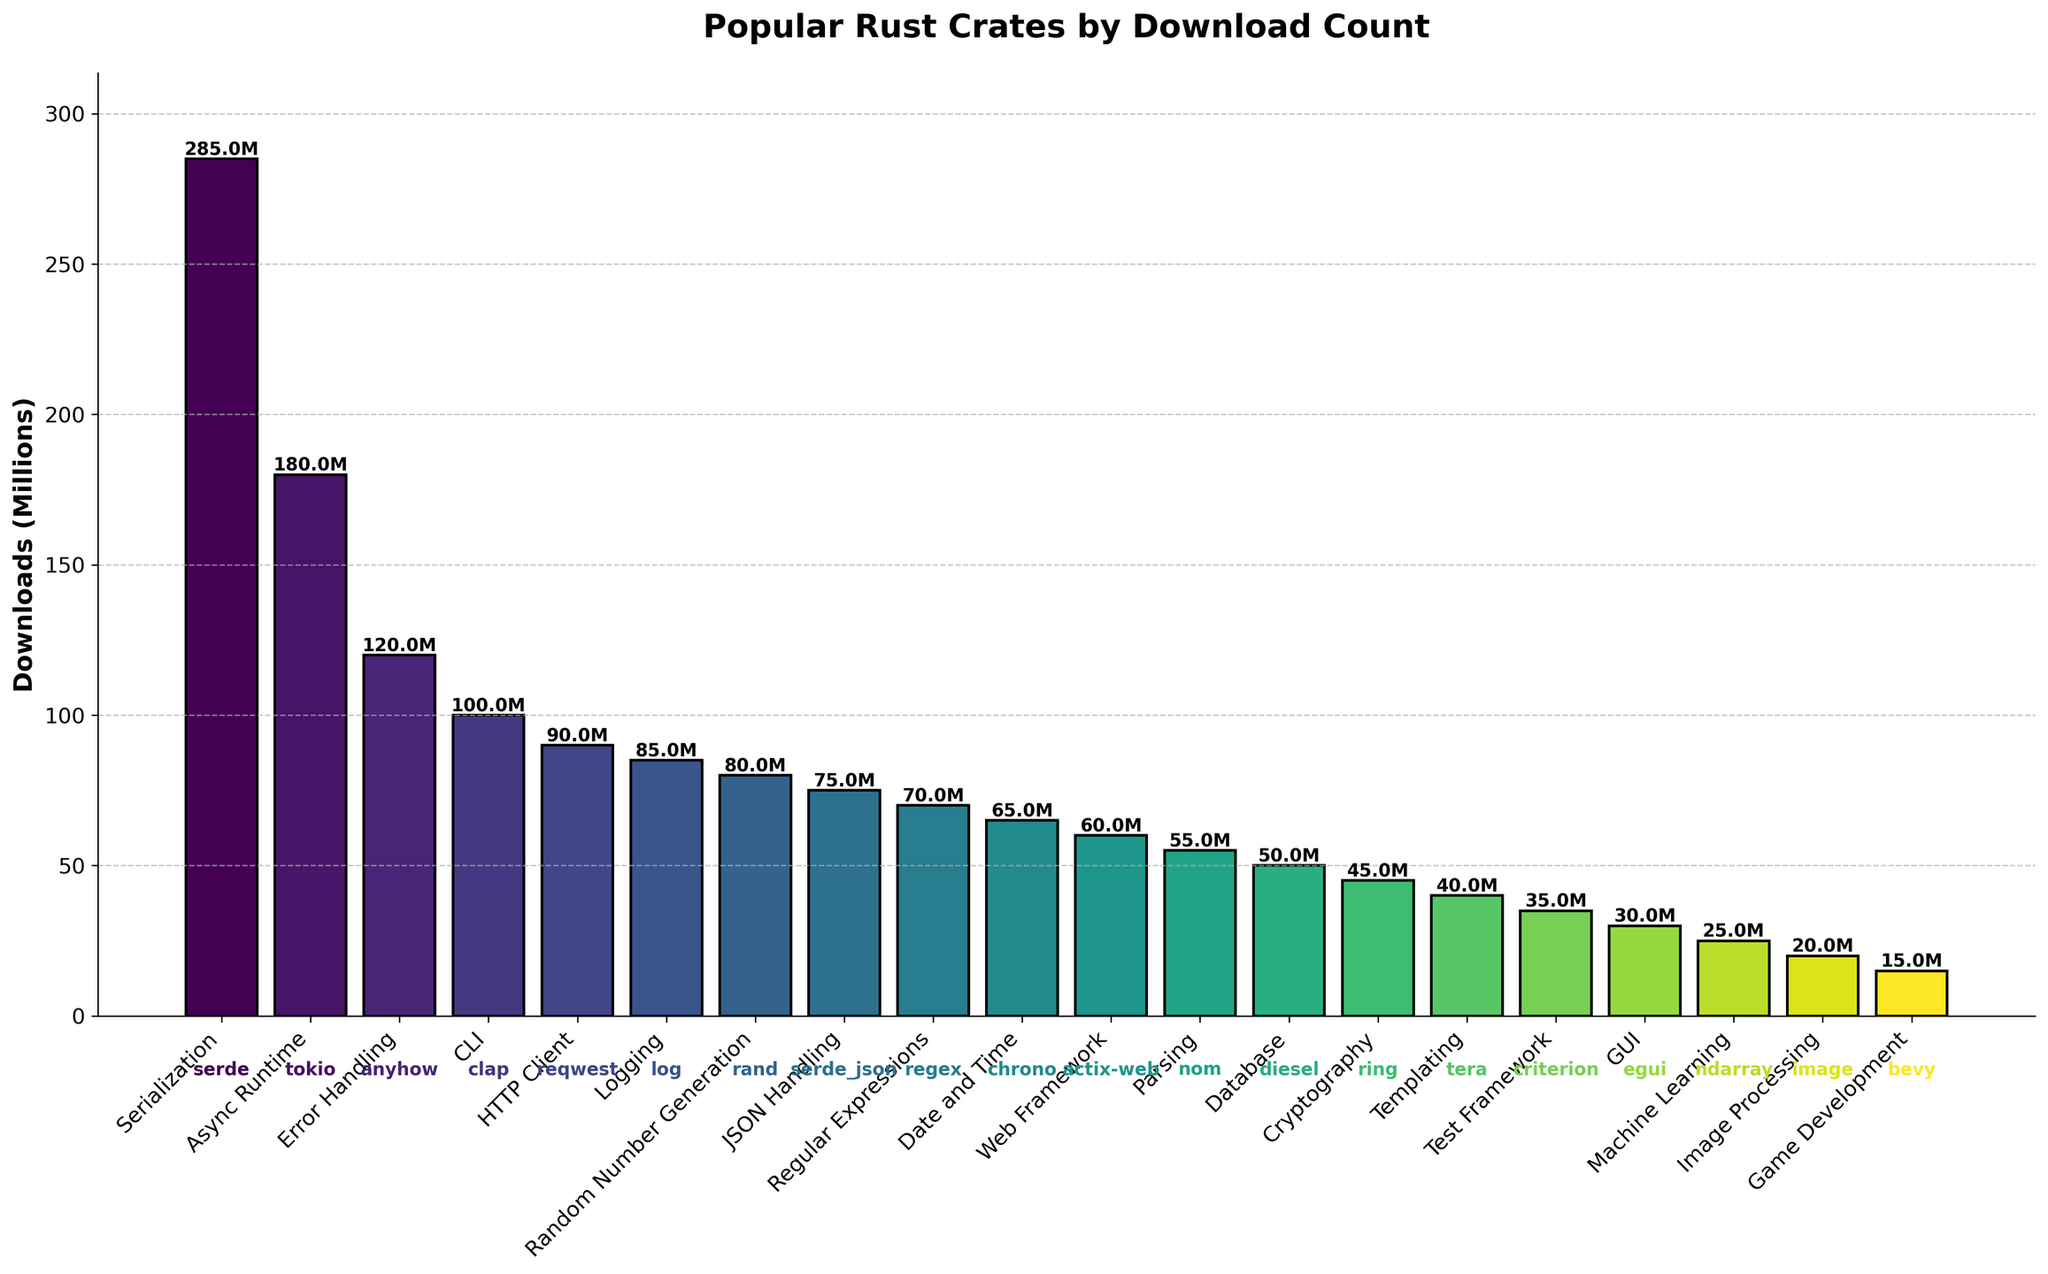Which crate category has the highest download count? In the bar chart, the tallest bar represents the crate category with the highest download count. The Serialization category (serde) has the tallest bar with a download count of 285 million.
Answer: Serialization What is the total download count for all categories combined? To get the total download count, we sum the heights of all bars. (285 + 180 + 120 + 100 + 90 + 85 + 80 + 75 + 70 + 65 + 60 + 55 + 50 + 45 + 40 + 35 + 30 + 25 + 20 + 15) million.
Answer: 1,550 million How does the download count of the HTTP Client category (reqwest) compare to the Database category (diesel)? Compare the heights of the bars representing the HTTP Client and Database categories. HTTP Client (reqwest) has 90 million downloads, while Database (diesel) has 50 million downloads.
Answer: HTTP Client > Database What is the difference in download counts between the Async Runtime category (tokio) and the Error Handling category (anyhow)? Subtract the shorter bar height from the taller bar height. Async Runtime (tokio) has 180 million downloads, and Error Handling (anyhow) has 120 million. The difference is 180 - 120.
Answer: 60 million What is the average download count for the top three crate categories? Calculate the sum of the download counts for the top three categories and divide by three. The top three are Serialization (285 million), Async Runtime (180 million), and Error Handling (120 million). (285 + 180 + 120) / 3
Answer: 195 million Which crate category has exactly half the downloads of the CLI category (clap)? Look for a bar that is half the height of the CLI category. CLI (clap) has 100 million downloads, and Random Number Generation (rand) has 50 million downloads.
Answer: Random Number Generation Is the download count of the Web Framework category (actix-web) closer to the count of the Parsing category (nom) or the Logging category (log)? Compare the differences in download counts. Web Framework (actix-web) has 60 million downloads, Parsing (nom) has 55 million, and Logging (log) has 85 million. 60 - 55 = 5 million, 85 - 60 = 25 million.
Answer: Parsing closer What is the median download count of all crate categories? Arrange the download counts in ascending order and identify the middle value. The download counts are (15, 20, 25, 30, 35, 40, 45, 50, 55, 60, 65, 70, 75, 80, 85, 90, 100, 120, 180, 285) million, so the median is the average of 50 and 55.
Answer: 52.5 million How much more popular is the crate in the Serialization category (serde) compared to the crate in the Machine Learning category (ndarray)? Compare the heights of the bars for Serialization and Machine Learning, then subtract the latter from the former. Serialization (serde) has 285 million downloads, and Machine Learning (ndarray) has 25 million. 285 - 25.
Answer: 260 million What primary function category represents the median crate in terms of download count? Arrange all bars in ascending order by download count and find the middle category. There are 19 categories, thus the median category is the 10th one when ordered. (15, 20, 25, 30, 35, 40, 45, 50, 55, *60*, 65, 70, 75, 80, 85, 90, 100, 120, 180, 285)
Answer: Web Framework 